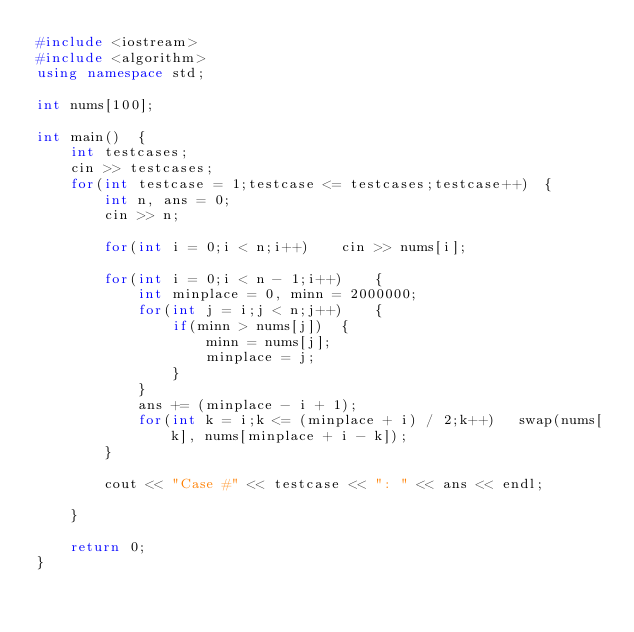<code> <loc_0><loc_0><loc_500><loc_500><_C++_>#include <iostream>
#include <algorithm>
using namespace std;

int nums[100];

int main()  {
    int testcases;
    cin >> testcases;
    for(int testcase = 1;testcase <= testcases;testcase++)  {
        int n, ans = 0;
        cin >> n;

        for(int i = 0;i < n;i++)    cin >> nums[i];

        for(int i = 0;i < n - 1;i++)    {
            int minplace = 0, minn = 2000000;
            for(int j = i;j < n;j++)    {
                if(minn > nums[j])  {
                    minn = nums[j];
                    minplace = j;
                }
            }
            ans += (minplace - i + 1);
            for(int k = i;k <= (minplace + i) / 2;k++)   swap(nums[k], nums[minplace + i - k]);
        }

        cout << "Case #" << testcase << ": " << ans << endl;

    }

    return 0;
}</code> 